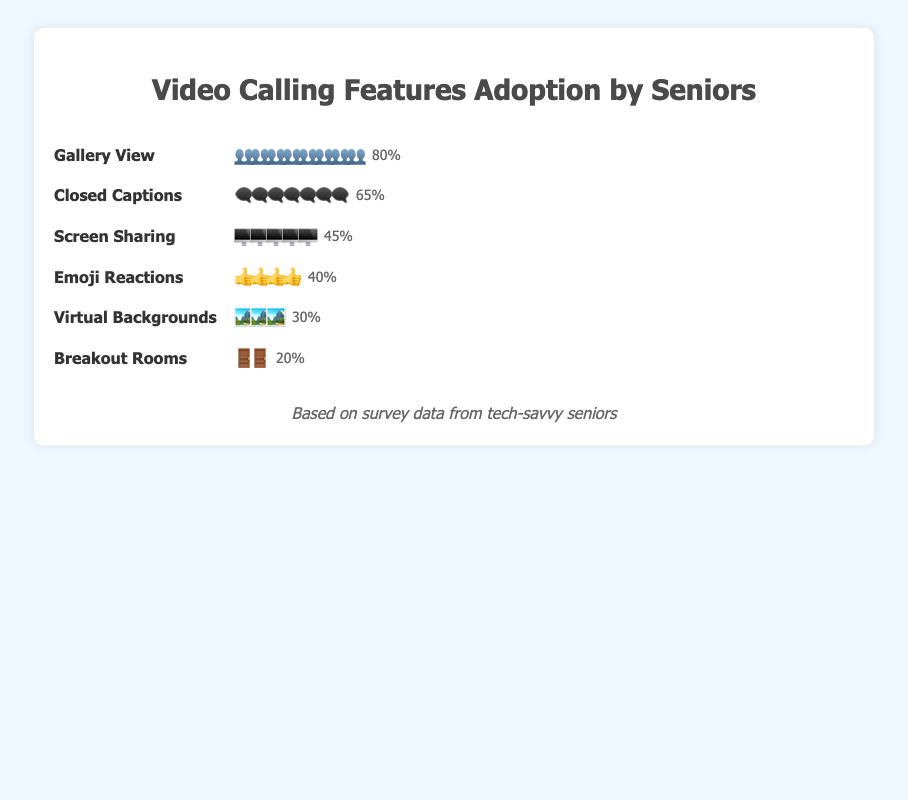Which video calling feature has the highest adoption rate among seniors? The Isotype Plot shows the adoption rate of different video calling features with corresponding icons. The feature with the most icons (👥) is Gallery View with an 80% adoption rate.
Answer: Gallery View Which video calling feature has the lowest adoption rate among seniors? The feature with the fewest icons (🚪) in the Isotype Plot is Breakout Rooms, which has an adoption rate of 20%.
Answer: Breakout Rooms What is the combined adoption rate of Screen Sharing and Emoji Reactions? Screen Sharing has an adoption rate of 45%, and Emoji Reactions has an adoption rate of 40%. Adding these rates together, 45% + 40% = 85%.
Answer: 85% How much higher is the adoption rate of Gallery View compared to Breakout Rooms? The adoption rate of Gallery View (80%) is higher than the adoption rate of Breakout Rooms (20%). The difference is 80% - 20% = 60%.
Answer: 60% Rank the features from highest to lowest adoption rate. By comparing the number of icons for each feature, we rank them as follows: Gallery View (80%), Closed Captions (65%), Screen Sharing (45%), Emoji Reactions (40%), Virtual Backgrounds (30%), and Breakout Rooms (20%).
Answer: Gallery View, Closed Captions, Screen Sharing, Emoji Reactions, Virtual Backgrounds, Breakout Rooms How does the adoption rate of Virtual Backgrounds compare to that of Emoji Reactions? Virtual Backgrounds have an adoption rate of 30%, while Emoji Reactions have a higher adoption rate of 40%.
Answer: Emoji Reactions have a higher adoption rate Which feature has more than a 50% adoption rate but less than 70%? Closed Captions have an adoption rate of 65%, which is more than 50% but less than 70%.
Answer: Closed Captions If the adoption rate of Closed Captions increases by 10%, what will it be? Currently, Closed Captions have an adoption rate of 65%. If it increases by 10%, the new rate will be 65% + 10% = 75%.
Answer: 75% What percentage of seniors have adopted features with less than 45% adoption rate? The features with less than 45% adoption rate are Virtual Backgrounds (30%) and Breakout Rooms (20%). Adding these, 30% + 20% = 50%.
Answer: 50% 